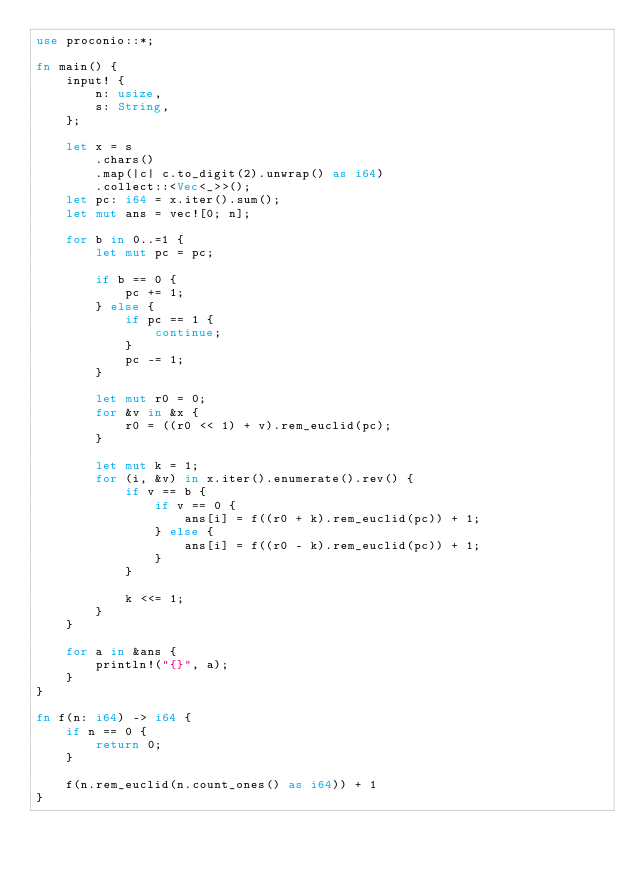<code> <loc_0><loc_0><loc_500><loc_500><_Rust_>use proconio::*;

fn main() {
    input! {
        n: usize,
        s: String,
    };

    let x = s
        .chars()
        .map(|c| c.to_digit(2).unwrap() as i64)
        .collect::<Vec<_>>();
    let pc: i64 = x.iter().sum();
    let mut ans = vec![0; n];

    for b in 0..=1 {
        let mut pc = pc;

        if b == 0 {
            pc += 1;
        } else {
            if pc == 1 {
                continue;
            }
            pc -= 1;
        }

        let mut r0 = 0;
        for &v in &x {
            r0 = ((r0 << 1) + v).rem_euclid(pc);
        }

        let mut k = 1;
        for (i, &v) in x.iter().enumerate().rev() {
            if v == b {
                if v == 0 {
                    ans[i] = f((r0 + k).rem_euclid(pc)) + 1;
                } else {
                    ans[i] = f((r0 - k).rem_euclid(pc)) + 1;
                }
            }

            k <<= 1;
        }
    }

    for a in &ans {
        println!("{}", a);
    }
}

fn f(n: i64) -> i64 {
    if n == 0 {
        return 0;
    }

    f(n.rem_euclid(n.count_ones() as i64)) + 1
}
</code> 